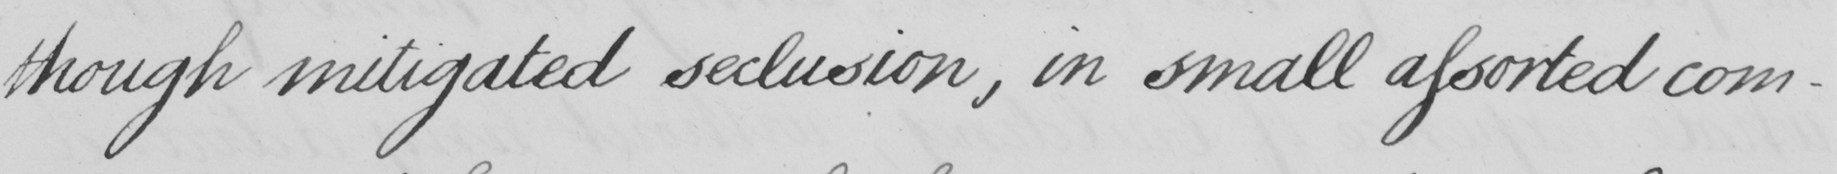Can you tell me what this handwritten text says? though mitigated seclusion, in small assorted com- 